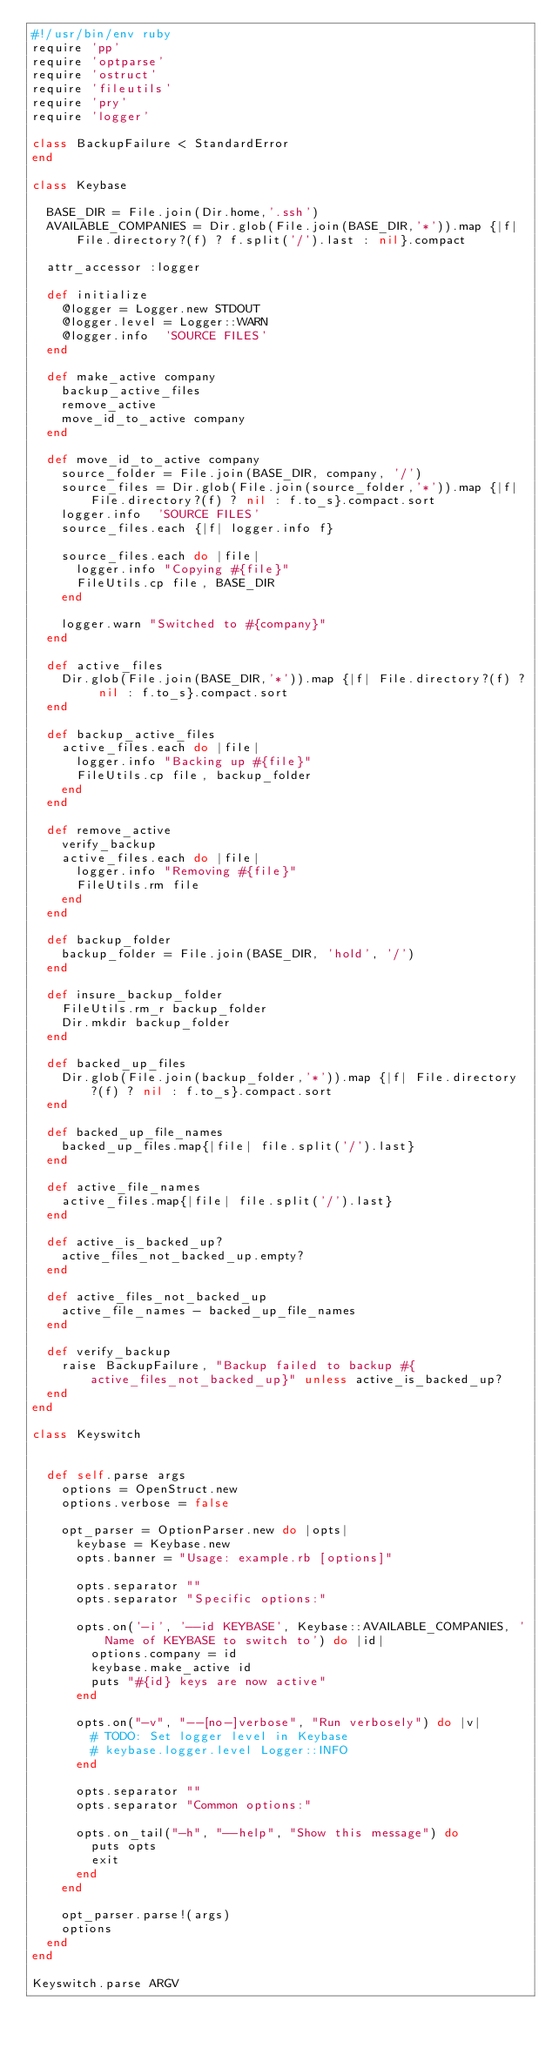Convert code to text. <code><loc_0><loc_0><loc_500><loc_500><_Ruby_>#!/usr/bin/env ruby
require 'pp'
require 'optparse'
require 'ostruct'
require 'fileutils'
require 'pry'
require 'logger'

class BackupFailure < StandardError
end

class Keybase

  BASE_DIR = File.join(Dir.home,'.ssh')
  AVAILABLE_COMPANIES = Dir.glob(File.join(BASE_DIR,'*')).map {|f| File.directory?(f) ? f.split('/').last : nil}.compact

  attr_accessor :logger

  def initialize
    @logger = Logger.new STDOUT
    @logger.level = Logger::WARN
    @logger.info  'SOURCE FILES'
  end

  def make_active company
    backup_active_files
    remove_active
    move_id_to_active company
  end

  def move_id_to_active company
    source_folder = File.join(BASE_DIR, company, '/')
    source_files = Dir.glob(File.join(source_folder,'*')).map {|f| File.directory?(f) ? nil : f.to_s}.compact.sort
    logger.info  'SOURCE FILES'
    source_files.each {|f| logger.info f}

    source_files.each do |file|
      logger.info "Copying #{file}"
      FileUtils.cp file, BASE_DIR
    end

    logger.warn "Switched to #{company}"
  end

  def active_files
    Dir.glob(File.join(BASE_DIR,'*')).map {|f| File.directory?(f) ? nil : f.to_s}.compact.sort
  end

  def backup_active_files
    active_files.each do |file|
      logger.info "Backing up #{file}"
      FileUtils.cp file, backup_folder
    end
  end

  def remove_active
    verify_backup
    active_files.each do |file|
      logger.info "Removing #{file}"
      FileUtils.rm file
    end
  end

  def backup_folder
    backup_folder = File.join(BASE_DIR, 'hold', '/')
  end

  def insure_backup_folder
    FileUtils.rm_r backup_folder
    Dir.mkdir backup_folder
  end

  def backed_up_files
    Dir.glob(File.join(backup_folder,'*')).map {|f| File.directory?(f) ? nil : f.to_s}.compact.sort
  end

  def backed_up_file_names
    backed_up_files.map{|file| file.split('/').last}
  end

  def active_file_names
    active_files.map{|file| file.split('/').last}
  end

  def active_is_backed_up?
    active_files_not_backed_up.empty?
  end

  def active_files_not_backed_up
    active_file_names - backed_up_file_names
  end

  def verify_backup
    raise BackupFailure, "Backup failed to backup #{active_files_not_backed_up}" unless active_is_backed_up?
  end
end

class Keyswitch


  def self.parse args
    options = OpenStruct.new
    options.verbose = false

    opt_parser = OptionParser.new do |opts|
      keybase = Keybase.new
      opts.banner = "Usage: example.rb [options]"

      opts.separator ""
      opts.separator "Specific options:"

      opts.on('-i', '--id KEYBASE', Keybase::AVAILABLE_COMPANIES, 'Name of KEYBASE to switch to') do |id|
        options.company = id
        keybase.make_active id
        puts "#{id} keys are now active"
      end

      opts.on("-v", "--[no-]verbose", "Run verbosely") do |v|
        # TODO: Set logger level in Keybase
        # keybase.logger.level Logger::INFO
      end

      opts.separator ""
      opts.separator "Common options:"

      opts.on_tail("-h", "--help", "Show this message") do
        puts opts
        exit
      end
    end

    opt_parser.parse!(args)
    options
  end
end

Keyswitch.parse ARGV
</code> 